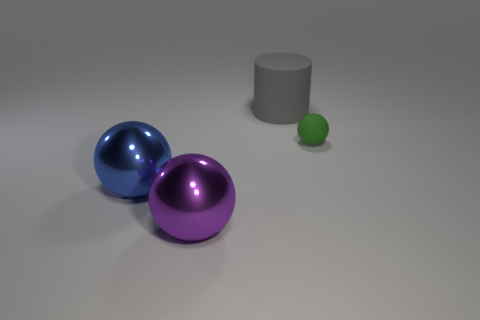Add 2 gray matte objects. How many objects exist? 6 Subtract all cylinders. How many objects are left? 3 Add 1 large blue things. How many large blue things exist? 2 Subtract 1 purple balls. How many objects are left? 3 Subtract all tiny green metallic cylinders. Subtract all gray rubber cylinders. How many objects are left? 3 Add 2 big blue spheres. How many big blue spheres are left? 3 